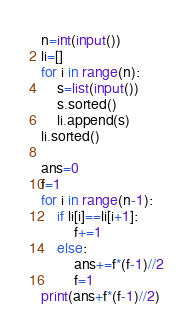<code> <loc_0><loc_0><loc_500><loc_500><_Python_>n=int(input())
li=[]
for i in range(n):
    s=list(input())
    s.sorted()
    li.append(s)
li.sorted()

ans=0
f=1
for i in range(n-1):
    if li[i]==li[i+1]:
        f+=1
    else:
        ans+=f*(f-1)//2
        f=1
print(ans+f*(f-1)//2)</code> 